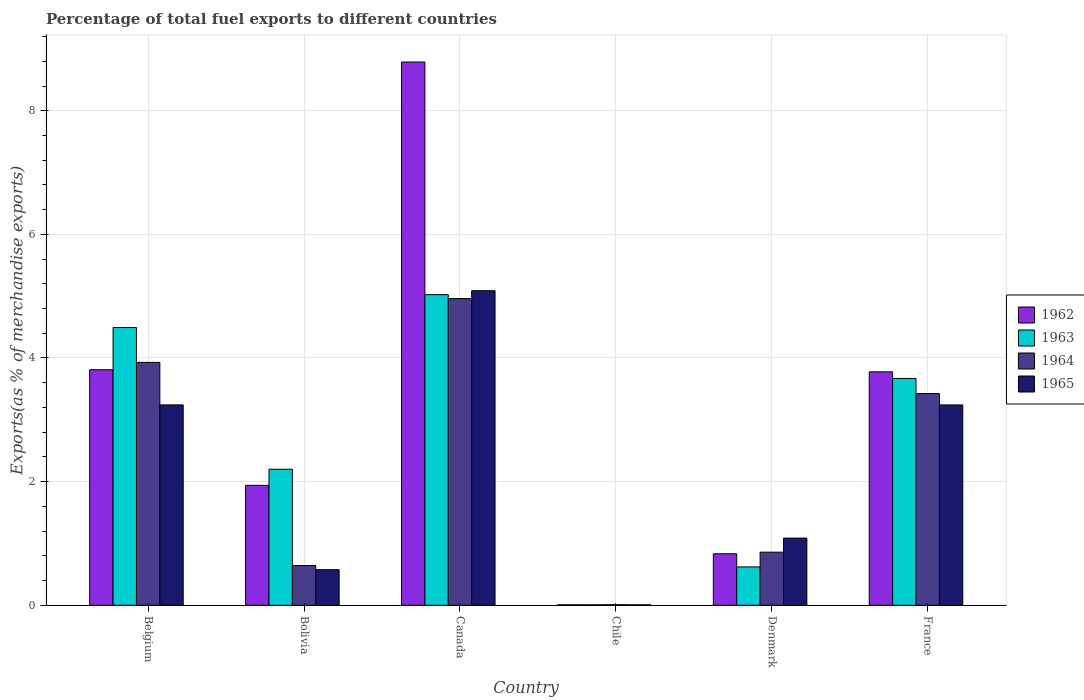How many bars are there on the 1st tick from the left?
Provide a short and direct response. 4. In how many cases, is the number of bars for a given country not equal to the number of legend labels?
Your answer should be compact. 0. What is the percentage of exports to different countries in 1964 in Bolivia?
Your answer should be compact. 0.64. Across all countries, what is the maximum percentage of exports to different countries in 1964?
Give a very brief answer. 4.96. Across all countries, what is the minimum percentage of exports to different countries in 1964?
Ensure brevity in your answer.  0.01. What is the total percentage of exports to different countries in 1965 in the graph?
Provide a succinct answer. 13.24. What is the difference between the percentage of exports to different countries in 1962 in Chile and that in France?
Offer a very short reply. -3.77. What is the difference between the percentage of exports to different countries in 1962 in Belgium and the percentage of exports to different countries in 1965 in France?
Offer a terse response. 0.57. What is the average percentage of exports to different countries in 1962 per country?
Your response must be concise. 3.19. What is the difference between the percentage of exports to different countries of/in 1965 and percentage of exports to different countries of/in 1964 in France?
Provide a succinct answer. -0.18. What is the ratio of the percentage of exports to different countries in 1962 in Canada to that in Chile?
Provide a short and direct response. 1254.38. Is the difference between the percentage of exports to different countries in 1965 in Belgium and France greater than the difference between the percentage of exports to different countries in 1964 in Belgium and France?
Give a very brief answer. No. What is the difference between the highest and the second highest percentage of exports to different countries in 1964?
Provide a short and direct response. -0.5. What is the difference between the highest and the lowest percentage of exports to different countries in 1964?
Provide a succinct answer. 4.95. Is it the case that in every country, the sum of the percentage of exports to different countries in 1963 and percentage of exports to different countries in 1965 is greater than the sum of percentage of exports to different countries in 1964 and percentage of exports to different countries in 1962?
Offer a very short reply. No. What does the 4th bar from the left in Belgium represents?
Provide a short and direct response. 1965. What does the 1st bar from the right in Belgium represents?
Ensure brevity in your answer.  1965. How many bars are there?
Offer a terse response. 24. How many countries are there in the graph?
Provide a succinct answer. 6. Are the values on the major ticks of Y-axis written in scientific E-notation?
Provide a succinct answer. No. Does the graph contain any zero values?
Give a very brief answer. No. Does the graph contain grids?
Make the answer very short. Yes. What is the title of the graph?
Your response must be concise. Percentage of total fuel exports to different countries. Does "1993" appear as one of the legend labels in the graph?
Provide a short and direct response. No. What is the label or title of the Y-axis?
Provide a short and direct response. Exports(as % of merchandise exports). What is the Exports(as % of merchandise exports) of 1962 in Belgium?
Ensure brevity in your answer.  3.81. What is the Exports(as % of merchandise exports) of 1963 in Belgium?
Offer a very short reply. 4.49. What is the Exports(as % of merchandise exports) of 1964 in Belgium?
Give a very brief answer. 3.93. What is the Exports(as % of merchandise exports) in 1965 in Belgium?
Provide a short and direct response. 3.24. What is the Exports(as % of merchandise exports) in 1962 in Bolivia?
Offer a terse response. 1.94. What is the Exports(as % of merchandise exports) in 1963 in Bolivia?
Provide a short and direct response. 2.2. What is the Exports(as % of merchandise exports) in 1964 in Bolivia?
Provide a succinct answer. 0.64. What is the Exports(as % of merchandise exports) of 1965 in Bolivia?
Your response must be concise. 0.58. What is the Exports(as % of merchandise exports) in 1962 in Canada?
Give a very brief answer. 8.79. What is the Exports(as % of merchandise exports) of 1963 in Canada?
Your response must be concise. 5.02. What is the Exports(as % of merchandise exports) in 1964 in Canada?
Ensure brevity in your answer.  4.96. What is the Exports(as % of merchandise exports) of 1965 in Canada?
Ensure brevity in your answer.  5.09. What is the Exports(as % of merchandise exports) in 1962 in Chile?
Your answer should be compact. 0.01. What is the Exports(as % of merchandise exports) of 1963 in Chile?
Ensure brevity in your answer.  0.01. What is the Exports(as % of merchandise exports) in 1964 in Chile?
Provide a succinct answer. 0.01. What is the Exports(as % of merchandise exports) of 1965 in Chile?
Provide a short and direct response. 0.01. What is the Exports(as % of merchandise exports) of 1962 in Denmark?
Your response must be concise. 0.83. What is the Exports(as % of merchandise exports) in 1963 in Denmark?
Your response must be concise. 0.62. What is the Exports(as % of merchandise exports) in 1964 in Denmark?
Ensure brevity in your answer.  0.86. What is the Exports(as % of merchandise exports) of 1965 in Denmark?
Your answer should be compact. 1.09. What is the Exports(as % of merchandise exports) of 1962 in France?
Give a very brief answer. 3.78. What is the Exports(as % of merchandise exports) of 1963 in France?
Your response must be concise. 3.67. What is the Exports(as % of merchandise exports) in 1964 in France?
Offer a very short reply. 3.43. What is the Exports(as % of merchandise exports) of 1965 in France?
Offer a very short reply. 3.24. Across all countries, what is the maximum Exports(as % of merchandise exports) of 1962?
Keep it short and to the point. 8.79. Across all countries, what is the maximum Exports(as % of merchandise exports) of 1963?
Your answer should be very brief. 5.02. Across all countries, what is the maximum Exports(as % of merchandise exports) of 1964?
Provide a succinct answer. 4.96. Across all countries, what is the maximum Exports(as % of merchandise exports) of 1965?
Give a very brief answer. 5.09. Across all countries, what is the minimum Exports(as % of merchandise exports) in 1962?
Your response must be concise. 0.01. Across all countries, what is the minimum Exports(as % of merchandise exports) in 1963?
Provide a short and direct response. 0.01. Across all countries, what is the minimum Exports(as % of merchandise exports) in 1964?
Your answer should be very brief. 0.01. Across all countries, what is the minimum Exports(as % of merchandise exports) in 1965?
Your answer should be compact. 0.01. What is the total Exports(as % of merchandise exports) of 1962 in the graph?
Provide a succinct answer. 19.15. What is the total Exports(as % of merchandise exports) of 1963 in the graph?
Offer a terse response. 16.02. What is the total Exports(as % of merchandise exports) in 1964 in the graph?
Provide a short and direct response. 13.83. What is the total Exports(as % of merchandise exports) of 1965 in the graph?
Keep it short and to the point. 13.24. What is the difference between the Exports(as % of merchandise exports) of 1962 in Belgium and that in Bolivia?
Ensure brevity in your answer.  1.87. What is the difference between the Exports(as % of merchandise exports) of 1963 in Belgium and that in Bolivia?
Offer a terse response. 2.29. What is the difference between the Exports(as % of merchandise exports) in 1964 in Belgium and that in Bolivia?
Your answer should be very brief. 3.29. What is the difference between the Exports(as % of merchandise exports) in 1965 in Belgium and that in Bolivia?
Provide a succinct answer. 2.67. What is the difference between the Exports(as % of merchandise exports) in 1962 in Belgium and that in Canada?
Ensure brevity in your answer.  -4.98. What is the difference between the Exports(as % of merchandise exports) of 1963 in Belgium and that in Canada?
Give a very brief answer. -0.53. What is the difference between the Exports(as % of merchandise exports) of 1964 in Belgium and that in Canada?
Offer a very short reply. -1.03. What is the difference between the Exports(as % of merchandise exports) of 1965 in Belgium and that in Canada?
Ensure brevity in your answer.  -1.85. What is the difference between the Exports(as % of merchandise exports) of 1962 in Belgium and that in Chile?
Your response must be concise. 3.8. What is the difference between the Exports(as % of merchandise exports) of 1963 in Belgium and that in Chile?
Your answer should be compact. 4.49. What is the difference between the Exports(as % of merchandise exports) in 1964 in Belgium and that in Chile?
Provide a short and direct response. 3.92. What is the difference between the Exports(as % of merchandise exports) of 1965 in Belgium and that in Chile?
Give a very brief answer. 3.23. What is the difference between the Exports(as % of merchandise exports) of 1962 in Belgium and that in Denmark?
Offer a terse response. 2.98. What is the difference between the Exports(as % of merchandise exports) of 1963 in Belgium and that in Denmark?
Provide a succinct answer. 3.87. What is the difference between the Exports(as % of merchandise exports) of 1964 in Belgium and that in Denmark?
Offer a terse response. 3.07. What is the difference between the Exports(as % of merchandise exports) of 1965 in Belgium and that in Denmark?
Keep it short and to the point. 2.15. What is the difference between the Exports(as % of merchandise exports) of 1962 in Belgium and that in France?
Give a very brief answer. 0.03. What is the difference between the Exports(as % of merchandise exports) of 1963 in Belgium and that in France?
Provide a succinct answer. 0.82. What is the difference between the Exports(as % of merchandise exports) in 1964 in Belgium and that in France?
Your answer should be compact. 0.5. What is the difference between the Exports(as % of merchandise exports) in 1965 in Belgium and that in France?
Make the answer very short. 0. What is the difference between the Exports(as % of merchandise exports) in 1962 in Bolivia and that in Canada?
Your response must be concise. -6.85. What is the difference between the Exports(as % of merchandise exports) of 1963 in Bolivia and that in Canada?
Your answer should be compact. -2.82. What is the difference between the Exports(as % of merchandise exports) of 1964 in Bolivia and that in Canada?
Provide a short and direct response. -4.32. What is the difference between the Exports(as % of merchandise exports) in 1965 in Bolivia and that in Canada?
Provide a succinct answer. -4.51. What is the difference between the Exports(as % of merchandise exports) in 1962 in Bolivia and that in Chile?
Provide a short and direct response. 1.93. What is the difference between the Exports(as % of merchandise exports) of 1963 in Bolivia and that in Chile?
Keep it short and to the point. 2.19. What is the difference between the Exports(as % of merchandise exports) in 1964 in Bolivia and that in Chile?
Ensure brevity in your answer.  0.63. What is the difference between the Exports(as % of merchandise exports) in 1965 in Bolivia and that in Chile?
Offer a very short reply. 0.57. What is the difference between the Exports(as % of merchandise exports) in 1962 in Bolivia and that in Denmark?
Your answer should be compact. 1.11. What is the difference between the Exports(as % of merchandise exports) of 1963 in Bolivia and that in Denmark?
Offer a very short reply. 1.58. What is the difference between the Exports(as % of merchandise exports) in 1964 in Bolivia and that in Denmark?
Make the answer very short. -0.22. What is the difference between the Exports(as % of merchandise exports) of 1965 in Bolivia and that in Denmark?
Provide a succinct answer. -0.51. What is the difference between the Exports(as % of merchandise exports) of 1962 in Bolivia and that in France?
Give a very brief answer. -1.84. What is the difference between the Exports(as % of merchandise exports) of 1963 in Bolivia and that in France?
Your answer should be very brief. -1.47. What is the difference between the Exports(as % of merchandise exports) of 1964 in Bolivia and that in France?
Provide a succinct answer. -2.78. What is the difference between the Exports(as % of merchandise exports) in 1965 in Bolivia and that in France?
Make the answer very short. -2.67. What is the difference between the Exports(as % of merchandise exports) of 1962 in Canada and that in Chile?
Provide a succinct answer. 8.78. What is the difference between the Exports(as % of merchandise exports) of 1963 in Canada and that in Chile?
Your answer should be compact. 5.02. What is the difference between the Exports(as % of merchandise exports) of 1964 in Canada and that in Chile?
Your response must be concise. 4.95. What is the difference between the Exports(as % of merchandise exports) of 1965 in Canada and that in Chile?
Your answer should be very brief. 5.08. What is the difference between the Exports(as % of merchandise exports) of 1962 in Canada and that in Denmark?
Your response must be concise. 7.95. What is the difference between the Exports(as % of merchandise exports) of 1963 in Canada and that in Denmark?
Your response must be concise. 4.4. What is the difference between the Exports(as % of merchandise exports) in 1964 in Canada and that in Denmark?
Offer a terse response. 4.1. What is the difference between the Exports(as % of merchandise exports) in 1965 in Canada and that in Denmark?
Offer a terse response. 4. What is the difference between the Exports(as % of merchandise exports) in 1962 in Canada and that in France?
Offer a terse response. 5.01. What is the difference between the Exports(as % of merchandise exports) of 1963 in Canada and that in France?
Make the answer very short. 1.36. What is the difference between the Exports(as % of merchandise exports) of 1964 in Canada and that in France?
Your answer should be very brief. 1.54. What is the difference between the Exports(as % of merchandise exports) in 1965 in Canada and that in France?
Make the answer very short. 1.85. What is the difference between the Exports(as % of merchandise exports) in 1962 in Chile and that in Denmark?
Provide a succinct answer. -0.83. What is the difference between the Exports(as % of merchandise exports) of 1963 in Chile and that in Denmark?
Provide a short and direct response. -0.61. What is the difference between the Exports(as % of merchandise exports) of 1964 in Chile and that in Denmark?
Ensure brevity in your answer.  -0.85. What is the difference between the Exports(as % of merchandise exports) of 1965 in Chile and that in Denmark?
Provide a short and direct response. -1.08. What is the difference between the Exports(as % of merchandise exports) of 1962 in Chile and that in France?
Your response must be concise. -3.77. What is the difference between the Exports(as % of merchandise exports) in 1963 in Chile and that in France?
Your answer should be very brief. -3.66. What is the difference between the Exports(as % of merchandise exports) in 1964 in Chile and that in France?
Ensure brevity in your answer.  -3.42. What is the difference between the Exports(as % of merchandise exports) in 1965 in Chile and that in France?
Your answer should be compact. -3.23. What is the difference between the Exports(as % of merchandise exports) of 1962 in Denmark and that in France?
Offer a very short reply. -2.94. What is the difference between the Exports(as % of merchandise exports) in 1963 in Denmark and that in France?
Your response must be concise. -3.05. What is the difference between the Exports(as % of merchandise exports) in 1964 in Denmark and that in France?
Your answer should be compact. -2.57. What is the difference between the Exports(as % of merchandise exports) of 1965 in Denmark and that in France?
Offer a very short reply. -2.15. What is the difference between the Exports(as % of merchandise exports) in 1962 in Belgium and the Exports(as % of merchandise exports) in 1963 in Bolivia?
Your response must be concise. 1.61. What is the difference between the Exports(as % of merchandise exports) of 1962 in Belgium and the Exports(as % of merchandise exports) of 1964 in Bolivia?
Your answer should be compact. 3.17. What is the difference between the Exports(as % of merchandise exports) in 1962 in Belgium and the Exports(as % of merchandise exports) in 1965 in Bolivia?
Keep it short and to the point. 3.23. What is the difference between the Exports(as % of merchandise exports) in 1963 in Belgium and the Exports(as % of merchandise exports) in 1964 in Bolivia?
Ensure brevity in your answer.  3.85. What is the difference between the Exports(as % of merchandise exports) of 1963 in Belgium and the Exports(as % of merchandise exports) of 1965 in Bolivia?
Your answer should be very brief. 3.92. What is the difference between the Exports(as % of merchandise exports) in 1964 in Belgium and the Exports(as % of merchandise exports) in 1965 in Bolivia?
Offer a very short reply. 3.35. What is the difference between the Exports(as % of merchandise exports) in 1962 in Belgium and the Exports(as % of merchandise exports) in 1963 in Canada?
Offer a very short reply. -1.21. What is the difference between the Exports(as % of merchandise exports) in 1962 in Belgium and the Exports(as % of merchandise exports) in 1964 in Canada?
Offer a very short reply. -1.15. What is the difference between the Exports(as % of merchandise exports) of 1962 in Belgium and the Exports(as % of merchandise exports) of 1965 in Canada?
Your answer should be very brief. -1.28. What is the difference between the Exports(as % of merchandise exports) in 1963 in Belgium and the Exports(as % of merchandise exports) in 1964 in Canada?
Your answer should be compact. -0.47. What is the difference between the Exports(as % of merchandise exports) in 1963 in Belgium and the Exports(as % of merchandise exports) in 1965 in Canada?
Provide a succinct answer. -0.6. What is the difference between the Exports(as % of merchandise exports) of 1964 in Belgium and the Exports(as % of merchandise exports) of 1965 in Canada?
Make the answer very short. -1.16. What is the difference between the Exports(as % of merchandise exports) in 1962 in Belgium and the Exports(as % of merchandise exports) in 1963 in Chile?
Provide a succinct answer. 3.8. What is the difference between the Exports(as % of merchandise exports) in 1962 in Belgium and the Exports(as % of merchandise exports) in 1964 in Chile?
Provide a short and direct response. 3.8. What is the difference between the Exports(as % of merchandise exports) in 1962 in Belgium and the Exports(as % of merchandise exports) in 1965 in Chile?
Provide a short and direct response. 3.8. What is the difference between the Exports(as % of merchandise exports) of 1963 in Belgium and the Exports(as % of merchandise exports) of 1964 in Chile?
Offer a terse response. 4.48. What is the difference between the Exports(as % of merchandise exports) in 1963 in Belgium and the Exports(as % of merchandise exports) in 1965 in Chile?
Your response must be concise. 4.49. What is the difference between the Exports(as % of merchandise exports) in 1964 in Belgium and the Exports(as % of merchandise exports) in 1965 in Chile?
Offer a very short reply. 3.92. What is the difference between the Exports(as % of merchandise exports) of 1962 in Belgium and the Exports(as % of merchandise exports) of 1963 in Denmark?
Provide a short and direct response. 3.19. What is the difference between the Exports(as % of merchandise exports) in 1962 in Belgium and the Exports(as % of merchandise exports) in 1964 in Denmark?
Provide a short and direct response. 2.95. What is the difference between the Exports(as % of merchandise exports) in 1962 in Belgium and the Exports(as % of merchandise exports) in 1965 in Denmark?
Provide a short and direct response. 2.72. What is the difference between the Exports(as % of merchandise exports) of 1963 in Belgium and the Exports(as % of merchandise exports) of 1964 in Denmark?
Make the answer very short. 3.63. What is the difference between the Exports(as % of merchandise exports) of 1963 in Belgium and the Exports(as % of merchandise exports) of 1965 in Denmark?
Give a very brief answer. 3.41. What is the difference between the Exports(as % of merchandise exports) in 1964 in Belgium and the Exports(as % of merchandise exports) in 1965 in Denmark?
Provide a succinct answer. 2.84. What is the difference between the Exports(as % of merchandise exports) of 1962 in Belgium and the Exports(as % of merchandise exports) of 1963 in France?
Your answer should be very brief. 0.14. What is the difference between the Exports(as % of merchandise exports) in 1962 in Belgium and the Exports(as % of merchandise exports) in 1964 in France?
Ensure brevity in your answer.  0.39. What is the difference between the Exports(as % of merchandise exports) of 1962 in Belgium and the Exports(as % of merchandise exports) of 1965 in France?
Your response must be concise. 0.57. What is the difference between the Exports(as % of merchandise exports) in 1963 in Belgium and the Exports(as % of merchandise exports) in 1964 in France?
Your answer should be compact. 1.07. What is the difference between the Exports(as % of merchandise exports) of 1963 in Belgium and the Exports(as % of merchandise exports) of 1965 in France?
Your answer should be very brief. 1.25. What is the difference between the Exports(as % of merchandise exports) of 1964 in Belgium and the Exports(as % of merchandise exports) of 1965 in France?
Offer a very short reply. 0.69. What is the difference between the Exports(as % of merchandise exports) in 1962 in Bolivia and the Exports(as % of merchandise exports) in 1963 in Canada?
Give a very brief answer. -3.08. What is the difference between the Exports(as % of merchandise exports) in 1962 in Bolivia and the Exports(as % of merchandise exports) in 1964 in Canada?
Offer a very short reply. -3.02. What is the difference between the Exports(as % of merchandise exports) in 1962 in Bolivia and the Exports(as % of merchandise exports) in 1965 in Canada?
Offer a very short reply. -3.15. What is the difference between the Exports(as % of merchandise exports) of 1963 in Bolivia and the Exports(as % of merchandise exports) of 1964 in Canada?
Provide a short and direct response. -2.76. What is the difference between the Exports(as % of merchandise exports) in 1963 in Bolivia and the Exports(as % of merchandise exports) in 1965 in Canada?
Offer a terse response. -2.89. What is the difference between the Exports(as % of merchandise exports) of 1964 in Bolivia and the Exports(as % of merchandise exports) of 1965 in Canada?
Your answer should be very brief. -4.45. What is the difference between the Exports(as % of merchandise exports) in 1962 in Bolivia and the Exports(as % of merchandise exports) in 1963 in Chile?
Make the answer very short. 1.93. What is the difference between the Exports(as % of merchandise exports) in 1962 in Bolivia and the Exports(as % of merchandise exports) in 1964 in Chile?
Ensure brevity in your answer.  1.93. What is the difference between the Exports(as % of merchandise exports) of 1962 in Bolivia and the Exports(as % of merchandise exports) of 1965 in Chile?
Keep it short and to the point. 1.93. What is the difference between the Exports(as % of merchandise exports) of 1963 in Bolivia and the Exports(as % of merchandise exports) of 1964 in Chile?
Offer a terse response. 2.19. What is the difference between the Exports(as % of merchandise exports) in 1963 in Bolivia and the Exports(as % of merchandise exports) in 1965 in Chile?
Give a very brief answer. 2.19. What is the difference between the Exports(as % of merchandise exports) of 1964 in Bolivia and the Exports(as % of merchandise exports) of 1965 in Chile?
Provide a short and direct response. 0.64. What is the difference between the Exports(as % of merchandise exports) in 1962 in Bolivia and the Exports(as % of merchandise exports) in 1963 in Denmark?
Your answer should be compact. 1.32. What is the difference between the Exports(as % of merchandise exports) of 1962 in Bolivia and the Exports(as % of merchandise exports) of 1964 in Denmark?
Provide a succinct answer. 1.08. What is the difference between the Exports(as % of merchandise exports) of 1962 in Bolivia and the Exports(as % of merchandise exports) of 1965 in Denmark?
Provide a short and direct response. 0.85. What is the difference between the Exports(as % of merchandise exports) in 1963 in Bolivia and the Exports(as % of merchandise exports) in 1964 in Denmark?
Offer a very short reply. 1.34. What is the difference between the Exports(as % of merchandise exports) in 1963 in Bolivia and the Exports(as % of merchandise exports) in 1965 in Denmark?
Your answer should be very brief. 1.11. What is the difference between the Exports(as % of merchandise exports) of 1964 in Bolivia and the Exports(as % of merchandise exports) of 1965 in Denmark?
Offer a terse response. -0.44. What is the difference between the Exports(as % of merchandise exports) in 1962 in Bolivia and the Exports(as % of merchandise exports) in 1963 in France?
Offer a terse response. -1.73. What is the difference between the Exports(as % of merchandise exports) in 1962 in Bolivia and the Exports(as % of merchandise exports) in 1964 in France?
Make the answer very short. -1.49. What is the difference between the Exports(as % of merchandise exports) in 1962 in Bolivia and the Exports(as % of merchandise exports) in 1965 in France?
Your answer should be very brief. -1.3. What is the difference between the Exports(as % of merchandise exports) of 1963 in Bolivia and the Exports(as % of merchandise exports) of 1964 in France?
Keep it short and to the point. -1.22. What is the difference between the Exports(as % of merchandise exports) in 1963 in Bolivia and the Exports(as % of merchandise exports) in 1965 in France?
Your answer should be very brief. -1.04. What is the difference between the Exports(as % of merchandise exports) in 1964 in Bolivia and the Exports(as % of merchandise exports) in 1965 in France?
Offer a very short reply. -2.6. What is the difference between the Exports(as % of merchandise exports) in 1962 in Canada and the Exports(as % of merchandise exports) in 1963 in Chile?
Give a very brief answer. 8.78. What is the difference between the Exports(as % of merchandise exports) in 1962 in Canada and the Exports(as % of merchandise exports) in 1964 in Chile?
Offer a terse response. 8.78. What is the difference between the Exports(as % of merchandise exports) in 1962 in Canada and the Exports(as % of merchandise exports) in 1965 in Chile?
Offer a terse response. 8.78. What is the difference between the Exports(as % of merchandise exports) of 1963 in Canada and the Exports(as % of merchandise exports) of 1964 in Chile?
Ensure brevity in your answer.  5.02. What is the difference between the Exports(as % of merchandise exports) in 1963 in Canada and the Exports(as % of merchandise exports) in 1965 in Chile?
Make the answer very short. 5.02. What is the difference between the Exports(as % of merchandise exports) in 1964 in Canada and the Exports(as % of merchandise exports) in 1965 in Chile?
Give a very brief answer. 4.95. What is the difference between the Exports(as % of merchandise exports) in 1962 in Canada and the Exports(as % of merchandise exports) in 1963 in Denmark?
Offer a very short reply. 8.17. What is the difference between the Exports(as % of merchandise exports) in 1962 in Canada and the Exports(as % of merchandise exports) in 1964 in Denmark?
Your response must be concise. 7.93. What is the difference between the Exports(as % of merchandise exports) of 1962 in Canada and the Exports(as % of merchandise exports) of 1965 in Denmark?
Your answer should be very brief. 7.7. What is the difference between the Exports(as % of merchandise exports) in 1963 in Canada and the Exports(as % of merchandise exports) in 1964 in Denmark?
Provide a succinct answer. 4.17. What is the difference between the Exports(as % of merchandise exports) in 1963 in Canada and the Exports(as % of merchandise exports) in 1965 in Denmark?
Your answer should be very brief. 3.94. What is the difference between the Exports(as % of merchandise exports) of 1964 in Canada and the Exports(as % of merchandise exports) of 1965 in Denmark?
Give a very brief answer. 3.87. What is the difference between the Exports(as % of merchandise exports) in 1962 in Canada and the Exports(as % of merchandise exports) in 1963 in France?
Keep it short and to the point. 5.12. What is the difference between the Exports(as % of merchandise exports) of 1962 in Canada and the Exports(as % of merchandise exports) of 1964 in France?
Offer a terse response. 5.36. What is the difference between the Exports(as % of merchandise exports) in 1962 in Canada and the Exports(as % of merchandise exports) in 1965 in France?
Provide a short and direct response. 5.55. What is the difference between the Exports(as % of merchandise exports) of 1963 in Canada and the Exports(as % of merchandise exports) of 1964 in France?
Your answer should be very brief. 1.6. What is the difference between the Exports(as % of merchandise exports) in 1963 in Canada and the Exports(as % of merchandise exports) in 1965 in France?
Ensure brevity in your answer.  1.78. What is the difference between the Exports(as % of merchandise exports) of 1964 in Canada and the Exports(as % of merchandise exports) of 1965 in France?
Provide a succinct answer. 1.72. What is the difference between the Exports(as % of merchandise exports) of 1962 in Chile and the Exports(as % of merchandise exports) of 1963 in Denmark?
Ensure brevity in your answer.  -0.61. What is the difference between the Exports(as % of merchandise exports) of 1962 in Chile and the Exports(as % of merchandise exports) of 1964 in Denmark?
Provide a succinct answer. -0.85. What is the difference between the Exports(as % of merchandise exports) of 1962 in Chile and the Exports(as % of merchandise exports) of 1965 in Denmark?
Offer a very short reply. -1.08. What is the difference between the Exports(as % of merchandise exports) in 1963 in Chile and the Exports(as % of merchandise exports) in 1964 in Denmark?
Make the answer very short. -0.85. What is the difference between the Exports(as % of merchandise exports) of 1963 in Chile and the Exports(as % of merchandise exports) of 1965 in Denmark?
Make the answer very short. -1.08. What is the difference between the Exports(as % of merchandise exports) of 1964 in Chile and the Exports(as % of merchandise exports) of 1965 in Denmark?
Provide a succinct answer. -1.08. What is the difference between the Exports(as % of merchandise exports) in 1962 in Chile and the Exports(as % of merchandise exports) in 1963 in France?
Offer a very short reply. -3.66. What is the difference between the Exports(as % of merchandise exports) in 1962 in Chile and the Exports(as % of merchandise exports) in 1964 in France?
Provide a succinct answer. -3.42. What is the difference between the Exports(as % of merchandise exports) of 1962 in Chile and the Exports(as % of merchandise exports) of 1965 in France?
Offer a terse response. -3.23. What is the difference between the Exports(as % of merchandise exports) in 1963 in Chile and the Exports(as % of merchandise exports) in 1964 in France?
Give a very brief answer. -3.42. What is the difference between the Exports(as % of merchandise exports) in 1963 in Chile and the Exports(as % of merchandise exports) in 1965 in France?
Offer a terse response. -3.23. What is the difference between the Exports(as % of merchandise exports) in 1964 in Chile and the Exports(as % of merchandise exports) in 1965 in France?
Your answer should be very brief. -3.23. What is the difference between the Exports(as % of merchandise exports) of 1962 in Denmark and the Exports(as % of merchandise exports) of 1963 in France?
Keep it short and to the point. -2.84. What is the difference between the Exports(as % of merchandise exports) of 1962 in Denmark and the Exports(as % of merchandise exports) of 1964 in France?
Provide a short and direct response. -2.59. What is the difference between the Exports(as % of merchandise exports) in 1962 in Denmark and the Exports(as % of merchandise exports) in 1965 in France?
Provide a succinct answer. -2.41. What is the difference between the Exports(as % of merchandise exports) of 1963 in Denmark and the Exports(as % of merchandise exports) of 1964 in France?
Offer a terse response. -2.8. What is the difference between the Exports(as % of merchandise exports) in 1963 in Denmark and the Exports(as % of merchandise exports) in 1965 in France?
Your answer should be compact. -2.62. What is the difference between the Exports(as % of merchandise exports) in 1964 in Denmark and the Exports(as % of merchandise exports) in 1965 in France?
Your answer should be very brief. -2.38. What is the average Exports(as % of merchandise exports) in 1962 per country?
Your answer should be very brief. 3.19. What is the average Exports(as % of merchandise exports) of 1963 per country?
Offer a very short reply. 2.67. What is the average Exports(as % of merchandise exports) in 1964 per country?
Your answer should be very brief. 2.3. What is the average Exports(as % of merchandise exports) in 1965 per country?
Your answer should be compact. 2.21. What is the difference between the Exports(as % of merchandise exports) of 1962 and Exports(as % of merchandise exports) of 1963 in Belgium?
Make the answer very short. -0.68. What is the difference between the Exports(as % of merchandise exports) in 1962 and Exports(as % of merchandise exports) in 1964 in Belgium?
Provide a short and direct response. -0.12. What is the difference between the Exports(as % of merchandise exports) in 1962 and Exports(as % of merchandise exports) in 1965 in Belgium?
Your answer should be compact. 0.57. What is the difference between the Exports(as % of merchandise exports) in 1963 and Exports(as % of merchandise exports) in 1964 in Belgium?
Your response must be concise. 0.56. What is the difference between the Exports(as % of merchandise exports) of 1963 and Exports(as % of merchandise exports) of 1965 in Belgium?
Keep it short and to the point. 1.25. What is the difference between the Exports(as % of merchandise exports) in 1964 and Exports(as % of merchandise exports) in 1965 in Belgium?
Offer a very short reply. 0.69. What is the difference between the Exports(as % of merchandise exports) of 1962 and Exports(as % of merchandise exports) of 1963 in Bolivia?
Offer a very short reply. -0.26. What is the difference between the Exports(as % of merchandise exports) in 1962 and Exports(as % of merchandise exports) in 1964 in Bolivia?
Make the answer very short. 1.3. What is the difference between the Exports(as % of merchandise exports) of 1962 and Exports(as % of merchandise exports) of 1965 in Bolivia?
Ensure brevity in your answer.  1.36. What is the difference between the Exports(as % of merchandise exports) in 1963 and Exports(as % of merchandise exports) in 1964 in Bolivia?
Make the answer very short. 1.56. What is the difference between the Exports(as % of merchandise exports) of 1963 and Exports(as % of merchandise exports) of 1965 in Bolivia?
Offer a terse response. 1.62. What is the difference between the Exports(as % of merchandise exports) in 1964 and Exports(as % of merchandise exports) in 1965 in Bolivia?
Offer a terse response. 0.07. What is the difference between the Exports(as % of merchandise exports) of 1962 and Exports(as % of merchandise exports) of 1963 in Canada?
Ensure brevity in your answer.  3.76. What is the difference between the Exports(as % of merchandise exports) of 1962 and Exports(as % of merchandise exports) of 1964 in Canada?
Your answer should be compact. 3.83. What is the difference between the Exports(as % of merchandise exports) in 1962 and Exports(as % of merchandise exports) in 1965 in Canada?
Your answer should be very brief. 3.7. What is the difference between the Exports(as % of merchandise exports) in 1963 and Exports(as % of merchandise exports) in 1964 in Canada?
Your answer should be very brief. 0.06. What is the difference between the Exports(as % of merchandise exports) in 1963 and Exports(as % of merchandise exports) in 1965 in Canada?
Your answer should be compact. -0.06. What is the difference between the Exports(as % of merchandise exports) in 1964 and Exports(as % of merchandise exports) in 1965 in Canada?
Your answer should be very brief. -0.13. What is the difference between the Exports(as % of merchandise exports) in 1962 and Exports(as % of merchandise exports) in 1963 in Chile?
Ensure brevity in your answer.  -0. What is the difference between the Exports(as % of merchandise exports) in 1962 and Exports(as % of merchandise exports) in 1964 in Chile?
Offer a very short reply. -0. What is the difference between the Exports(as % of merchandise exports) of 1963 and Exports(as % of merchandise exports) of 1964 in Chile?
Offer a terse response. -0. What is the difference between the Exports(as % of merchandise exports) in 1964 and Exports(as % of merchandise exports) in 1965 in Chile?
Ensure brevity in your answer.  0. What is the difference between the Exports(as % of merchandise exports) in 1962 and Exports(as % of merchandise exports) in 1963 in Denmark?
Keep it short and to the point. 0.21. What is the difference between the Exports(as % of merchandise exports) of 1962 and Exports(as % of merchandise exports) of 1964 in Denmark?
Keep it short and to the point. -0.03. What is the difference between the Exports(as % of merchandise exports) in 1962 and Exports(as % of merchandise exports) in 1965 in Denmark?
Give a very brief answer. -0.25. What is the difference between the Exports(as % of merchandise exports) in 1963 and Exports(as % of merchandise exports) in 1964 in Denmark?
Offer a very short reply. -0.24. What is the difference between the Exports(as % of merchandise exports) in 1963 and Exports(as % of merchandise exports) in 1965 in Denmark?
Offer a terse response. -0.47. What is the difference between the Exports(as % of merchandise exports) in 1964 and Exports(as % of merchandise exports) in 1965 in Denmark?
Keep it short and to the point. -0.23. What is the difference between the Exports(as % of merchandise exports) in 1962 and Exports(as % of merchandise exports) in 1963 in France?
Keep it short and to the point. 0.11. What is the difference between the Exports(as % of merchandise exports) in 1962 and Exports(as % of merchandise exports) in 1964 in France?
Keep it short and to the point. 0.35. What is the difference between the Exports(as % of merchandise exports) in 1962 and Exports(as % of merchandise exports) in 1965 in France?
Your answer should be compact. 0.54. What is the difference between the Exports(as % of merchandise exports) of 1963 and Exports(as % of merchandise exports) of 1964 in France?
Offer a very short reply. 0.24. What is the difference between the Exports(as % of merchandise exports) of 1963 and Exports(as % of merchandise exports) of 1965 in France?
Provide a short and direct response. 0.43. What is the difference between the Exports(as % of merchandise exports) in 1964 and Exports(as % of merchandise exports) in 1965 in France?
Ensure brevity in your answer.  0.18. What is the ratio of the Exports(as % of merchandise exports) in 1962 in Belgium to that in Bolivia?
Offer a very short reply. 1.96. What is the ratio of the Exports(as % of merchandise exports) of 1963 in Belgium to that in Bolivia?
Your response must be concise. 2.04. What is the ratio of the Exports(as % of merchandise exports) in 1964 in Belgium to that in Bolivia?
Give a very brief answer. 6.12. What is the ratio of the Exports(as % of merchandise exports) in 1965 in Belgium to that in Bolivia?
Ensure brevity in your answer.  5.63. What is the ratio of the Exports(as % of merchandise exports) of 1962 in Belgium to that in Canada?
Make the answer very short. 0.43. What is the ratio of the Exports(as % of merchandise exports) in 1963 in Belgium to that in Canada?
Provide a short and direct response. 0.89. What is the ratio of the Exports(as % of merchandise exports) in 1964 in Belgium to that in Canada?
Provide a short and direct response. 0.79. What is the ratio of the Exports(as % of merchandise exports) in 1965 in Belgium to that in Canada?
Your response must be concise. 0.64. What is the ratio of the Exports(as % of merchandise exports) in 1962 in Belgium to that in Chile?
Offer a very short reply. 543.89. What is the ratio of the Exports(as % of merchandise exports) in 1963 in Belgium to that in Chile?
Make the answer very short. 634.23. What is the ratio of the Exports(as % of merchandise exports) of 1964 in Belgium to that in Chile?
Give a very brief answer. 439.88. What is the ratio of the Exports(as % of merchandise exports) of 1965 in Belgium to that in Chile?
Provide a succinct answer. 479.5. What is the ratio of the Exports(as % of merchandise exports) of 1962 in Belgium to that in Denmark?
Ensure brevity in your answer.  4.57. What is the ratio of the Exports(as % of merchandise exports) in 1963 in Belgium to that in Denmark?
Ensure brevity in your answer.  7.24. What is the ratio of the Exports(as % of merchandise exports) in 1964 in Belgium to that in Denmark?
Give a very brief answer. 4.57. What is the ratio of the Exports(as % of merchandise exports) in 1965 in Belgium to that in Denmark?
Make the answer very short. 2.98. What is the ratio of the Exports(as % of merchandise exports) in 1962 in Belgium to that in France?
Make the answer very short. 1.01. What is the ratio of the Exports(as % of merchandise exports) of 1963 in Belgium to that in France?
Your answer should be compact. 1.22. What is the ratio of the Exports(as % of merchandise exports) in 1964 in Belgium to that in France?
Give a very brief answer. 1.15. What is the ratio of the Exports(as % of merchandise exports) in 1965 in Belgium to that in France?
Your answer should be very brief. 1. What is the ratio of the Exports(as % of merchandise exports) in 1962 in Bolivia to that in Canada?
Make the answer very short. 0.22. What is the ratio of the Exports(as % of merchandise exports) of 1963 in Bolivia to that in Canada?
Your response must be concise. 0.44. What is the ratio of the Exports(as % of merchandise exports) of 1964 in Bolivia to that in Canada?
Provide a succinct answer. 0.13. What is the ratio of the Exports(as % of merchandise exports) of 1965 in Bolivia to that in Canada?
Your answer should be very brief. 0.11. What is the ratio of the Exports(as % of merchandise exports) of 1962 in Bolivia to that in Chile?
Give a very brief answer. 276.87. What is the ratio of the Exports(as % of merchandise exports) in 1963 in Bolivia to that in Chile?
Offer a terse response. 310.59. What is the ratio of the Exports(as % of merchandise exports) of 1964 in Bolivia to that in Chile?
Ensure brevity in your answer.  71.92. What is the ratio of the Exports(as % of merchandise exports) in 1965 in Bolivia to that in Chile?
Make the answer very short. 85.13. What is the ratio of the Exports(as % of merchandise exports) in 1962 in Bolivia to that in Denmark?
Offer a very short reply. 2.33. What is the ratio of the Exports(as % of merchandise exports) in 1963 in Bolivia to that in Denmark?
Your answer should be compact. 3.55. What is the ratio of the Exports(as % of merchandise exports) of 1964 in Bolivia to that in Denmark?
Your response must be concise. 0.75. What is the ratio of the Exports(as % of merchandise exports) of 1965 in Bolivia to that in Denmark?
Offer a very short reply. 0.53. What is the ratio of the Exports(as % of merchandise exports) in 1962 in Bolivia to that in France?
Ensure brevity in your answer.  0.51. What is the ratio of the Exports(as % of merchandise exports) of 1963 in Bolivia to that in France?
Provide a succinct answer. 0.6. What is the ratio of the Exports(as % of merchandise exports) of 1964 in Bolivia to that in France?
Your response must be concise. 0.19. What is the ratio of the Exports(as % of merchandise exports) of 1965 in Bolivia to that in France?
Keep it short and to the point. 0.18. What is the ratio of the Exports(as % of merchandise exports) in 1962 in Canada to that in Chile?
Provide a short and direct response. 1254.38. What is the ratio of the Exports(as % of merchandise exports) of 1963 in Canada to that in Chile?
Provide a succinct answer. 709.22. What is the ratio of the Exports(as % of merchandise exports) in 1964 in Canada to that in Chile?
Offer a terse response. 555.45. What is the ratio of the Exports(as % of merchandise exports) in 1965 in Canada to that in Chile?
Your answer should be compact. 752.83. What is the ratio of the Exports(as % of merchandise exports) in 1962 in Canada to that in Denmark?
Your answer should be compact. 10.55. What is the ratio of the Exports(as % of merchandise exports) of 1963 in Canada to that in Denmark?
Your answer should be very brief. 8.1. What is the ratio of the Exports(as % of merchandise exports) in 1964 in Canada to that in Denmark?
Keep it short and to the point. 5.78. What is the ratio of the Exports(as % of merchandise exports) in 1965 in Canada to that in Denmark?
Your answer should be compact. 4.68. What is the ratio of the Exports(as % of merchandise exports) in 1962 in Canada to that in France?
Ensure brevity in your answer.  2.33. What is the ratio of the Exports(as % of merchandise exports) in 1963 in Canada to that in France?
Ensure brevity in your answer.  1.37. What is the ratio of the Exports(as % of merchandise exports) in 1964 in Canada to that in France?
Provide a short and direct response. 1.45. What is the ratio of the Exports(as % of merchandise exports) in 1965 in Canada to that in France?
Provide a succinct answer. 1.57. What is the ratio of the Exports(as % of merchandise exports) of 1962 in Chile to that in Denmark?
Your response must be concise. 0.01. What is the ratio of the Exports(as % of merchandise exports) of 1963 in Chile to that in Denmark?
Ensure brevity in your answer.  0.01. What is the ratio of the Exports(as % of merchandise exports) of 1964 in Chile to that in Denmark?
Your answer should be compact. 0.01. What is the ratio of the Exports(as % of merchandise exports) in 1965 in Chile to that in Denmark?
Keep it short and to the point. 0.01. What is the ratio of the Exports(as % of merchandise exports) of 1962 in Chile to that in France?
Make the answer very short. 0. What is the ratio of the Exports(as % of merchandise exports) of 1963 in Chile to that in France?
Your response must be concise. 0. What is the ratio of the Exports(as % of merchandise exports) in 1964 in Chile to that in France?
Offer a terse response. 0. What is the ratio of the Exports(as % of merchandise exports) of 1965 in Chile to that in France?
Your answer should be compact. 0. What is the ratio of the Exports(as % of merchandise exports) in 1962 in Denmark to that in France?
Keep it short and to the point. 0.22. What is the ratio of the Exports(as % of merchandise exports) of 1963 in Denmark to that in France?
Offer a very short reply. 0.17. What is the ratio of the Exports(as % of merchandise exports) of 1964 in Denmark to that in France?
Your answer should be very brief. 0.25. What is the ratio of the Exports(as % of merchandise exports) of 1965 in Denmark to that in France?
Your answer should be very brief. 0.34. What is the difference between the highest and the second highest Exports(as % of merchandise exports) in 1962?
Make the answer very short. 4.98. What is the difference between the highest and the second highest Exports(as % of merchandise exports) in 1963?
Give a very brief answer. 0.53. What is the difference between the highest and the second highest Exports(as % of merchandise exports) in 1964?
Your response must be concise. 1.03. What is the difference between the highest and the second highest Exports(as % of merchandise exports) in 1965?
Your answer should be compact. 1.85. What is the difference between the highest and the lowest Exports(as % of merchandise exports) in 1962?
Give a very brief answer. 8.78. What is the difference between the highest and the lowest Exports(as % of merchandise exports) in 1963?
Offer a terse response. 5.02. What is the difference between the highest and the lowest Exports(as % of merchandise exports) of 1964?
Offer a terse response. 4.95. What is the difference between the highest and the lowest Exports(as % of merchandise exports) of 1965?
Your answer should be very brief. 5.08. 